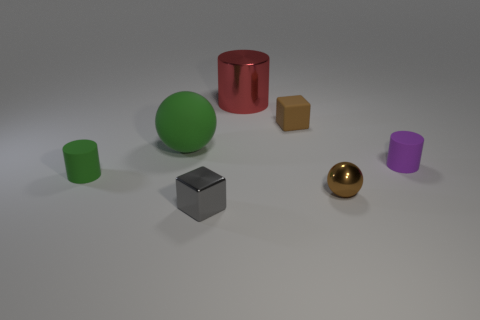The small cube that is behind the tiny gray metallic block that is on the left side of the brown rubber object that is behind the small metallic sphere is made of what material?
Your response must be concise. Rubber. Is the color of the tiny ball the same as the metallic cylinder?
Your response must be concise. No. Are there any large shiny objects that have the same color as the rubber cube?
Keep it short and to the point. No. What shape is the green object that is the same size as the brown rubber cube?
Your answer should be compact. Cylinder. Are there fewer purple things than big green cubes?
Make the answer very short. No. What number of shiny blocks are the same size as the red cylinder?
Your response must be concise. 0. There is a small rubber thing that is the same color as the tiny ball; what is its shape?
Your response must be concise. Cube. What is the small green object made of?
Offer a very short reply. Rubber. There is a metal thing that is behind the brown matte object; what is its size?
Offer a terse response. Large. What number of other small purple rubber things have the same shape as the purple thing?
Keep it short and to the point. 0. 